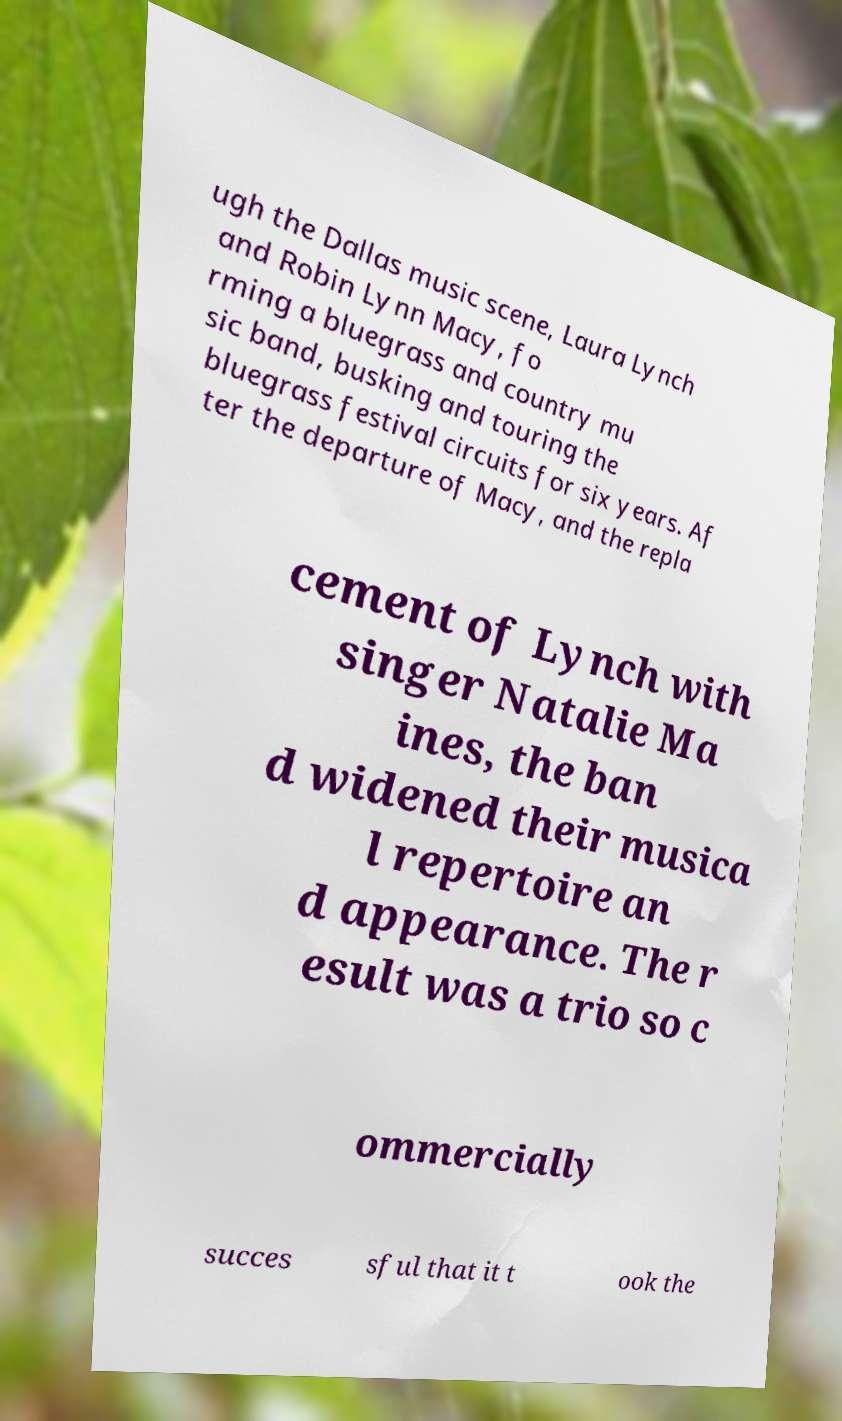Can you accurately transcribe the text from the provided image for me? ugh the Dallas music scene, Laura Lynch and Robin Lynn Macy, fo rming a bluegrass and country mu sic band, busking and touring the bluegrass festival circuits for six years. Af ter the departure of Macy, and the repla cement of Lynch with singer Natalie Ma ines, the ban d widened their musica l repertoire an d appearance. The r esult was a trio so c ommercially succes sful that it t ook the 